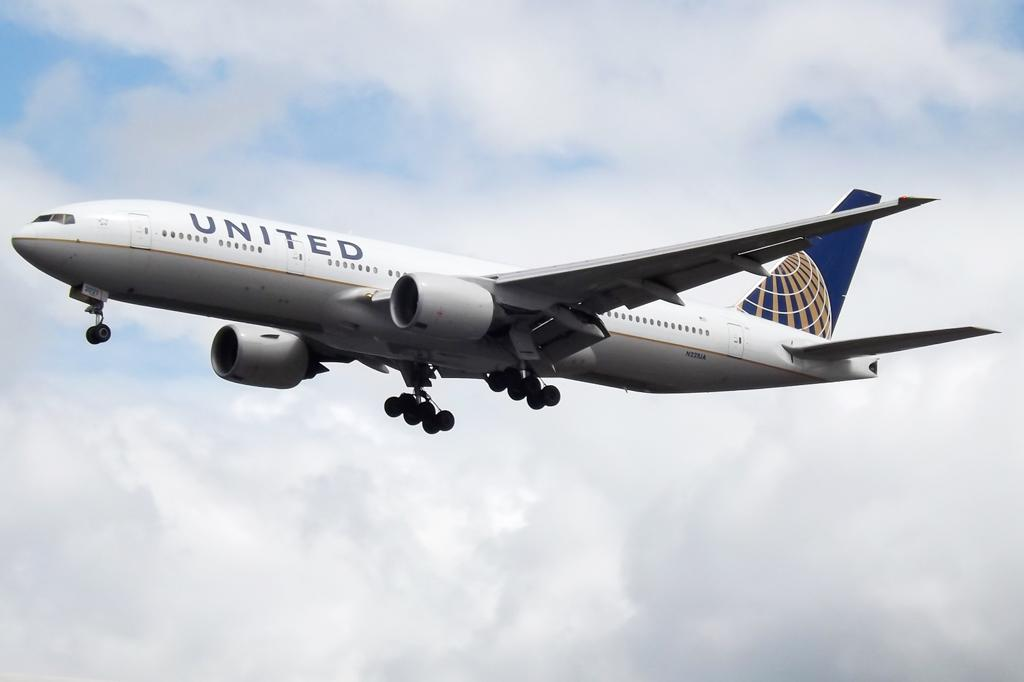<image>
Share a concise interpretation of the image provided. A united airlines plane flies through the sky. 